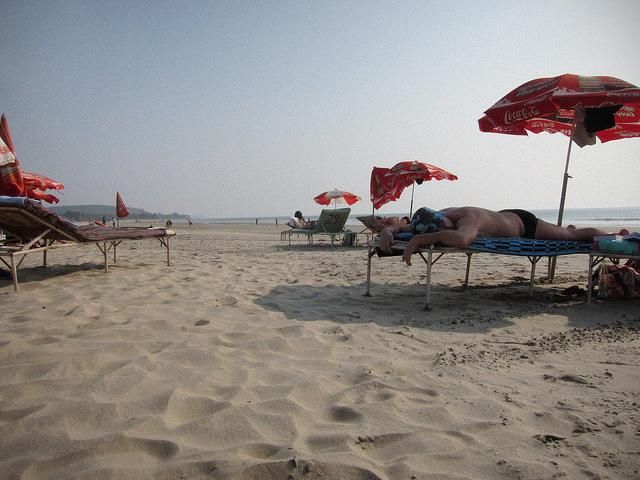The man lying down uses the umbrella for what? Please explain your reasoning. shade. It surely isn't raining and without this protection he is going to get a nasty sunburn. 